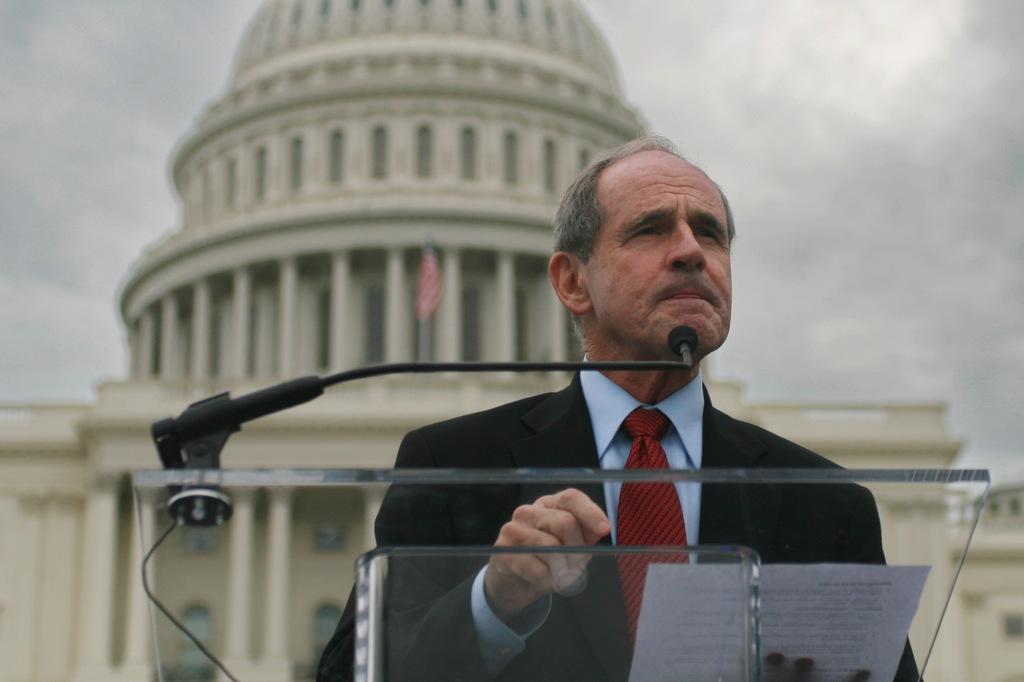How would you summarize this image in a sentence or two? As we can see in the image in the front there is a man wearing black color jacket and holding a paper. In the background there is a building, flag and sky. 